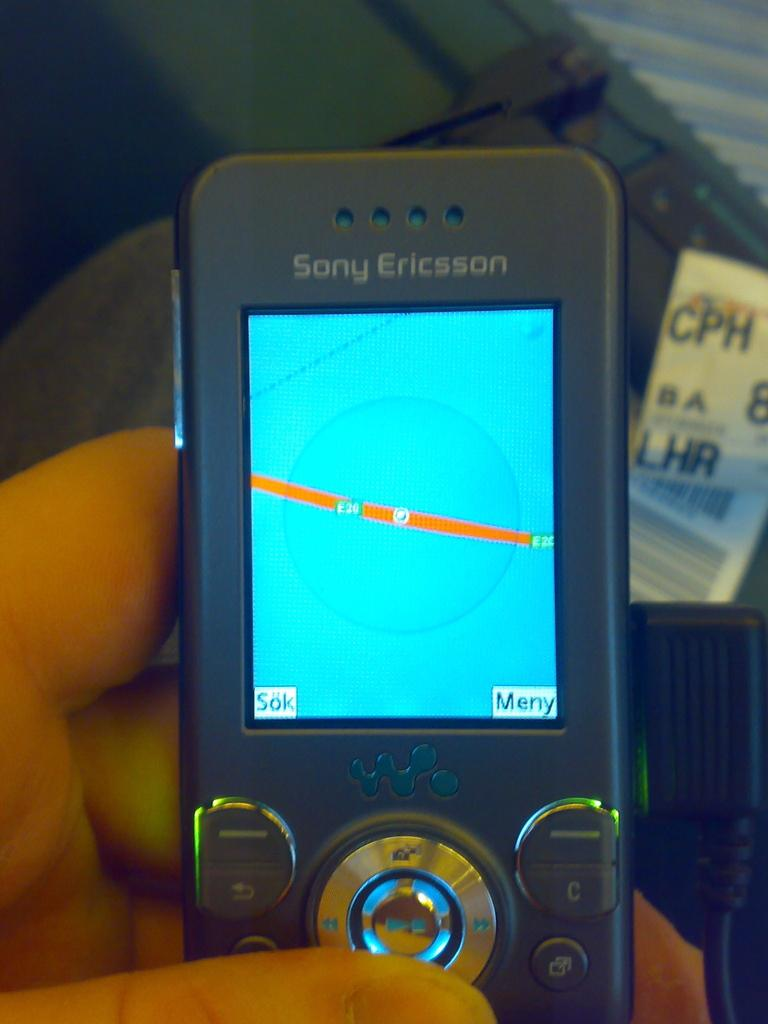Provide a one-sentence caption for the provided image. An old Sony Ericsson phone showing navigation screen. 